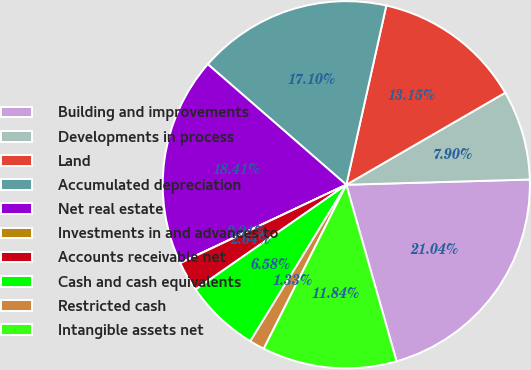<chart> <loc_0><loc_0><loc_500><loc_500><pie_chart><fcel>Building and improvements<fcel>Developments in process<fcel>Land<fcel>Accumulated depreciation<fcel>Net real estate<fcel>Investments in and advances to<fcel>Accounts receivable net<fcel>Cash and cash equivalents<fcel>Restricted cash<fcel>Intangible assets net<nl><fcel>21.04%<fcel>7.9%<fcel>13.15%<fcel>17.1%<fcel>18.41%<fcel>0.01%<fcel>2.64%<fcel>6.58%<fcel>1.33%<fcel>11.84%<nl></chart> 